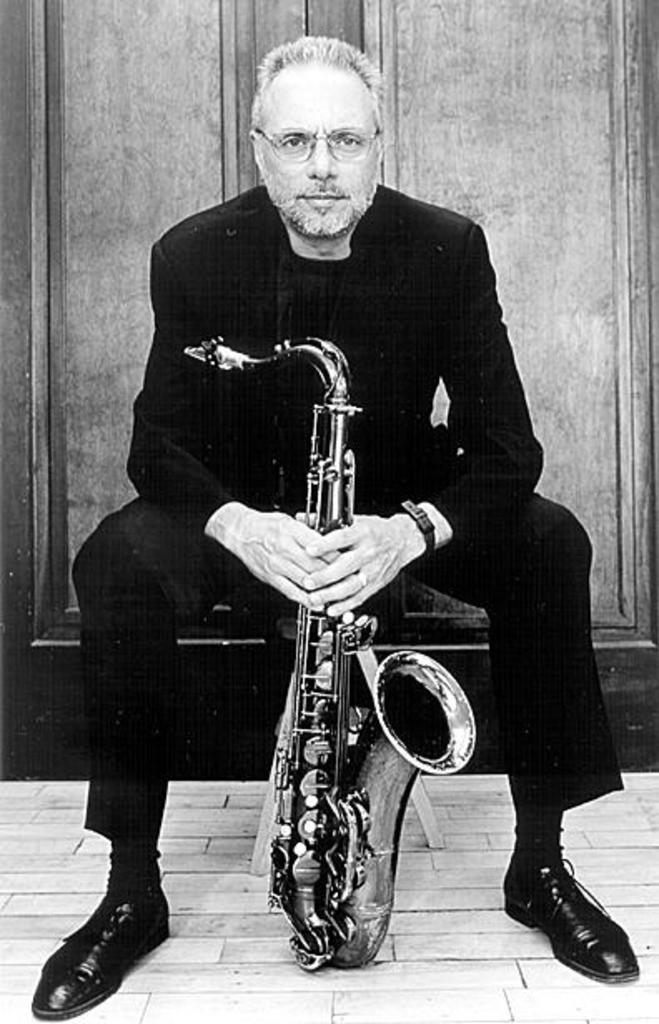What is the main subject in the foreground of the image? There is a person in the foreground of the image. What is the person holding in the image? The person is holding a musical instrument. What can be seen in the background of the image? There is a door visible in the background of the image. What type of cloth is being used to express a belief during the voyage in the image? There is no cloth, belief, or voyage present in the image. 